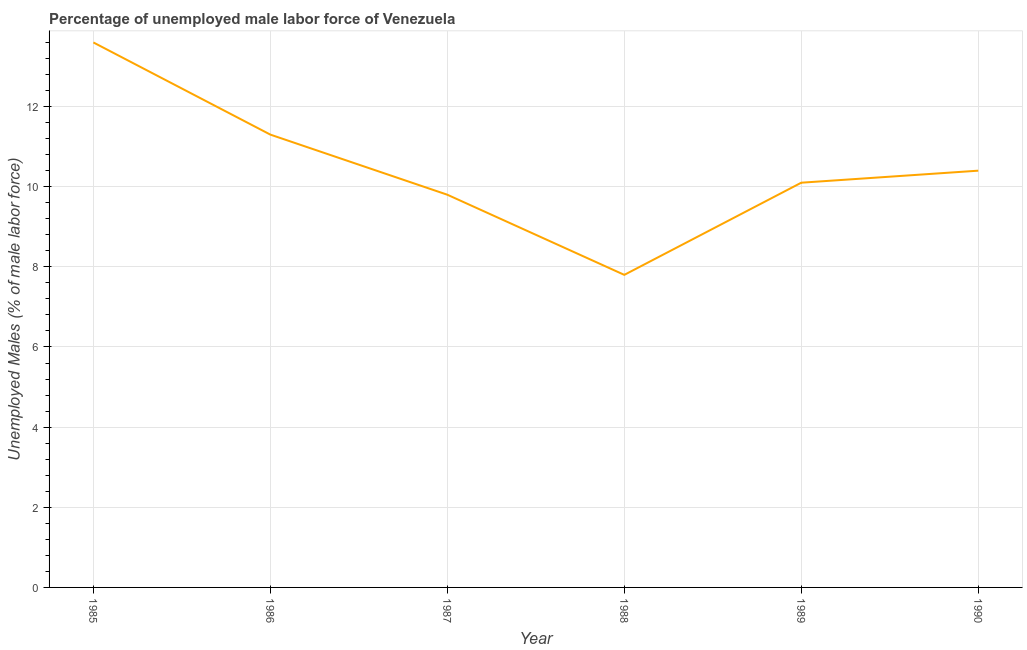What is the total unemployed male labour force in 1985?
Provide a short and direct response. 13.6. Across all years, what is the maximum total unemployed male labour force?
Provide a short and direct response. 13.6. Across all years, what is the minimum total unemployed male labour force?
Give a very brief answer. 7.8. In which year was the total unemployed male labour force maximum?
Make the answer very short. 1985. What is the sum of the total unemployed male labour force?
Your answer should be very brief. 63. What is the difference between the total unemployed male labour force in 1986 and 1989?
Offer a terse response. 1.2. What is the average total unemployed male labour force per year?
Provide a short and direct response. 10.5. What is the median total unemployed male labour force?
Keep it short and to the point. 10.25. What is the ratio of the total unemployed male labour force in 1985 to that in 1988?
Provide a succinct answer. 1.74. Is the difference between the total unemployed male labour force in 1985 and 1988 greater than the difference between any two years?
Your answer should be compact. Yes. What is the difference between the highest and the second highest total unemployed male labour force?
Make the answer very short. 2.3. What is the difference between the highest and the lowest total unemployed male labour force?
Your answer should be very brief. 5.8. Does the graph contain any zero values?
Make the answer very short. No. Does the graph contain grids?
Keep it short and to the point. Yes. What is the title of the graph?
Your answer should be very brief. Percentage of unemployed male labor force of Venezuela. What is the label or title of the X-axis?
Your answer should be very brief. Year. What is the label or title of the Y-axis?
Keep it short and to the point. Unemployed Males (% of male labor force). What is the Unemployed Males (% of male labor force) of 1985?
Make the answer very short. 13.6. What is the Unemployed Males (% of male labor force) of 1986?
Ensure brevity in your answer.  11.3. What is the Unemployed Males (% of male labor force) of 1987?
Keep it short and to the point. 9.8. What is the Unemployed Males (% of male labor force) in 1988?
Give a very brief answer. 7.8. What is the Unemployed Males (% of male labor force) in 1989?
Offer a very short reply. 10.1. What is the Unemployed Males (% of male labor force) of 1990?
Provide a succinct answer. 10.4. What is the difference between the Unemployed Males (% of male labor force) in 1985 and 1989?
Provide a succinct answer. 3.5. What is the difference between the Unemployed Males (% of male labor force) in 1986 and 1987?
Ensure brevity in your answer.  1.5. What is the difference between the Unemployed Males (% of male labor force) in 1986 and 1988?
Ensure brevity in your answer.  3.5. What is the difference between the Unemployed Males (% of male labor force) in 1987 and 1990?
Keep it short and to the point. -0.6. What is the ratio of the Unemployed Males (% of male labor force) in 1985 to that in 1986?
Give a very brief answer. 1.2. What is the ratio of the Unemployed Males (% of male labor force) in 1985 to that in 1987?
Offer a very short reply. 1.39. What is the ratio of the Unemployed Males (% of male labor force) in 1985 to that in 1988?
Give a very brief answer. 1.74. What is the ratio of the Unemployed Males (% of male labor force) in 1985 to that in 1989?
Keep it short and to the point. 1.35. What is the ratio of the Unemployed Males (% of male labor force) in 1985 to that in 1990?
Offer a terse response. 1.31. What is the ratio of the Unemployed Males (% of male labor force) in 1986 to that in 1987?
Give a very brief answer. 1.15. What is the ratio of the Unemployed Males (% of male labor force) in 1986 to that in 1988?
Give a very brief answer. 1.45. What is the ratio of the Unemployed Males (% of male labor force) in 1986 to that in 1989?
Provide a succinct answer. 1.12. What is the ratio of the Unemployed Males (% of male labor force) in 1986 to that in 1990?
Provide a short and direct response. 1.09. What is the ratio of the Unemployed Males (% of male labor force) in 1987 to that in 1988?
Your response must be concise. 1.26. What is the ratio of the Unemployed Males (% of male labor force) in 1987 to that in 1989?
Provide a succinct answer. 0.97. What is the ratio of the Unemployed Males (% of male labor force) in 1987 to that in 1990?
Ensure brevity in your answer.  0.94. What is the ratio of the Unemployed Males (% of male labor force) in 1988 to that in 1989?
Give a very brief answer. 0.77. What is the ratio of the Unemployed Males (% of male labor force) in 1988 to that in 1990?
Make the answer very short. 0.75. 